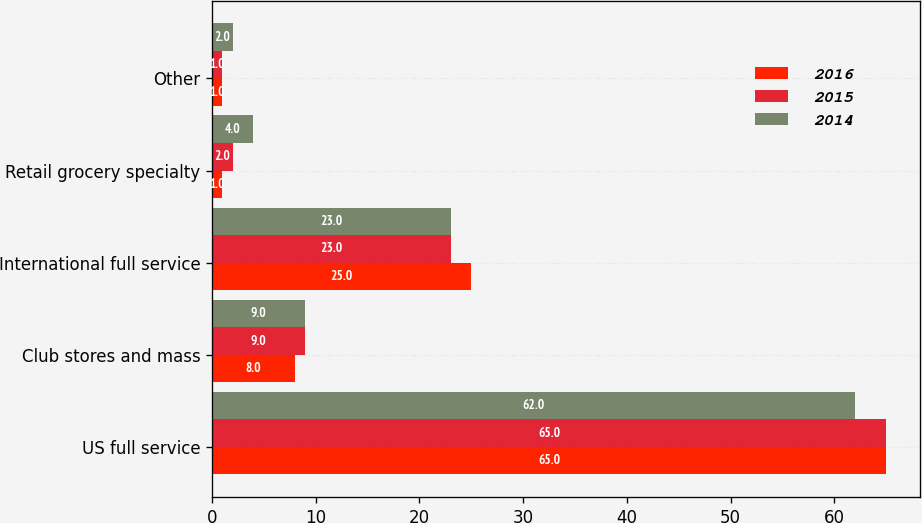Convert chart. <chart><loc_0><loc_0><loc_500><loc_500><stacked_bar_chart><ecel><fcel>US full service<fcel>Club stores and mass<fcel>International full service<fcel>Retail grocery specialty<fcel>Other<nl><fcel>2016<fcel>65<fcel>8<fcel>25<fcel>1<fcel>1<nl><fcel>2015<fcel>65<fcel>9<fcel>23<fcel>2<fcel>1<nl><fcel>2014<fcel>62<fcel>9<fcel>23<fcel>4<fcel>2<nl></chart> 